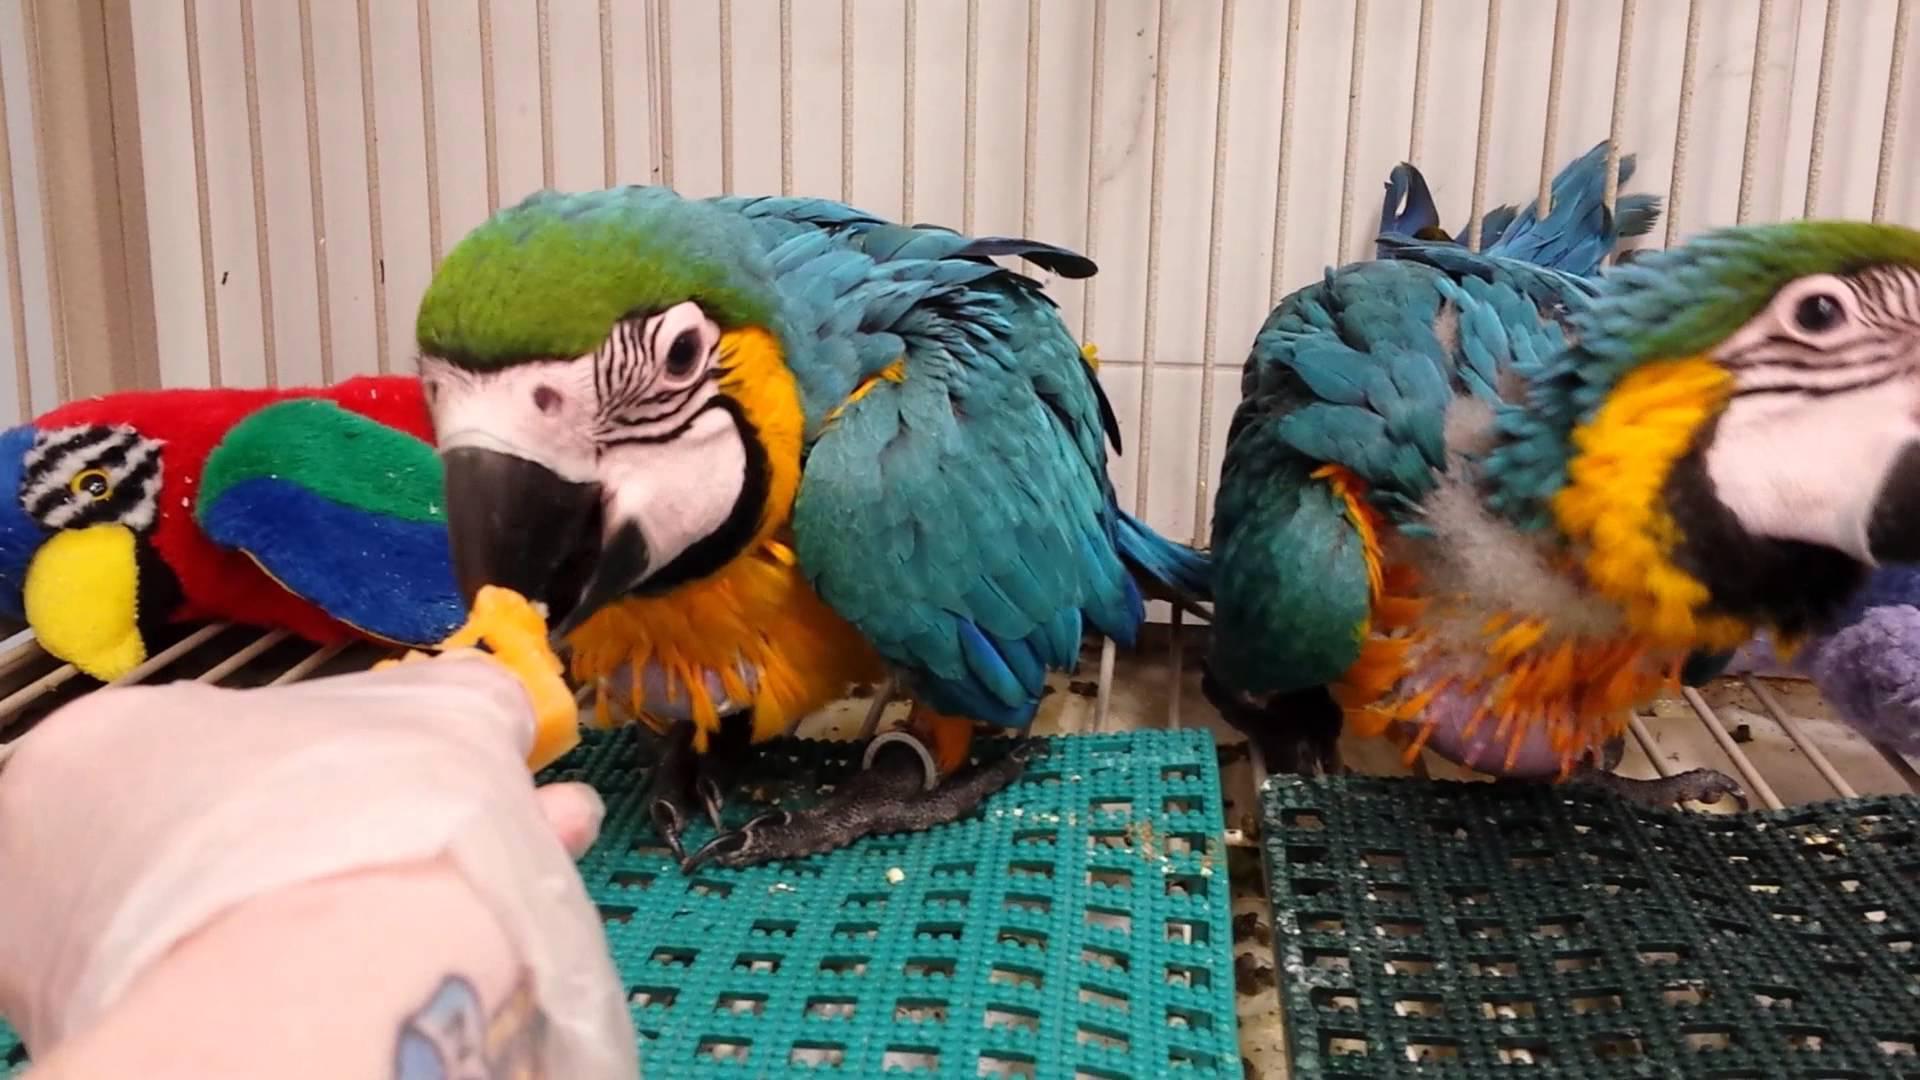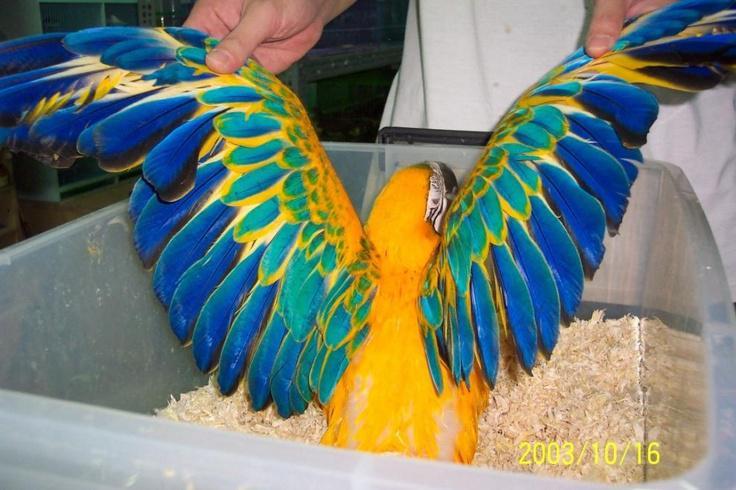The first image is the image on the left, the second image is the image on the right. Given the left and right images, does the statement "there are 3 parrots in the image pair" hold true? Answer yes or no. Yes. The first image is the image on the left, the second image is the image on the right. Examine the images to the left and right. Is the description "In one image there is a blue parrot sitting on a perch in the center of the image." accurate? Answer yes or no. No. 